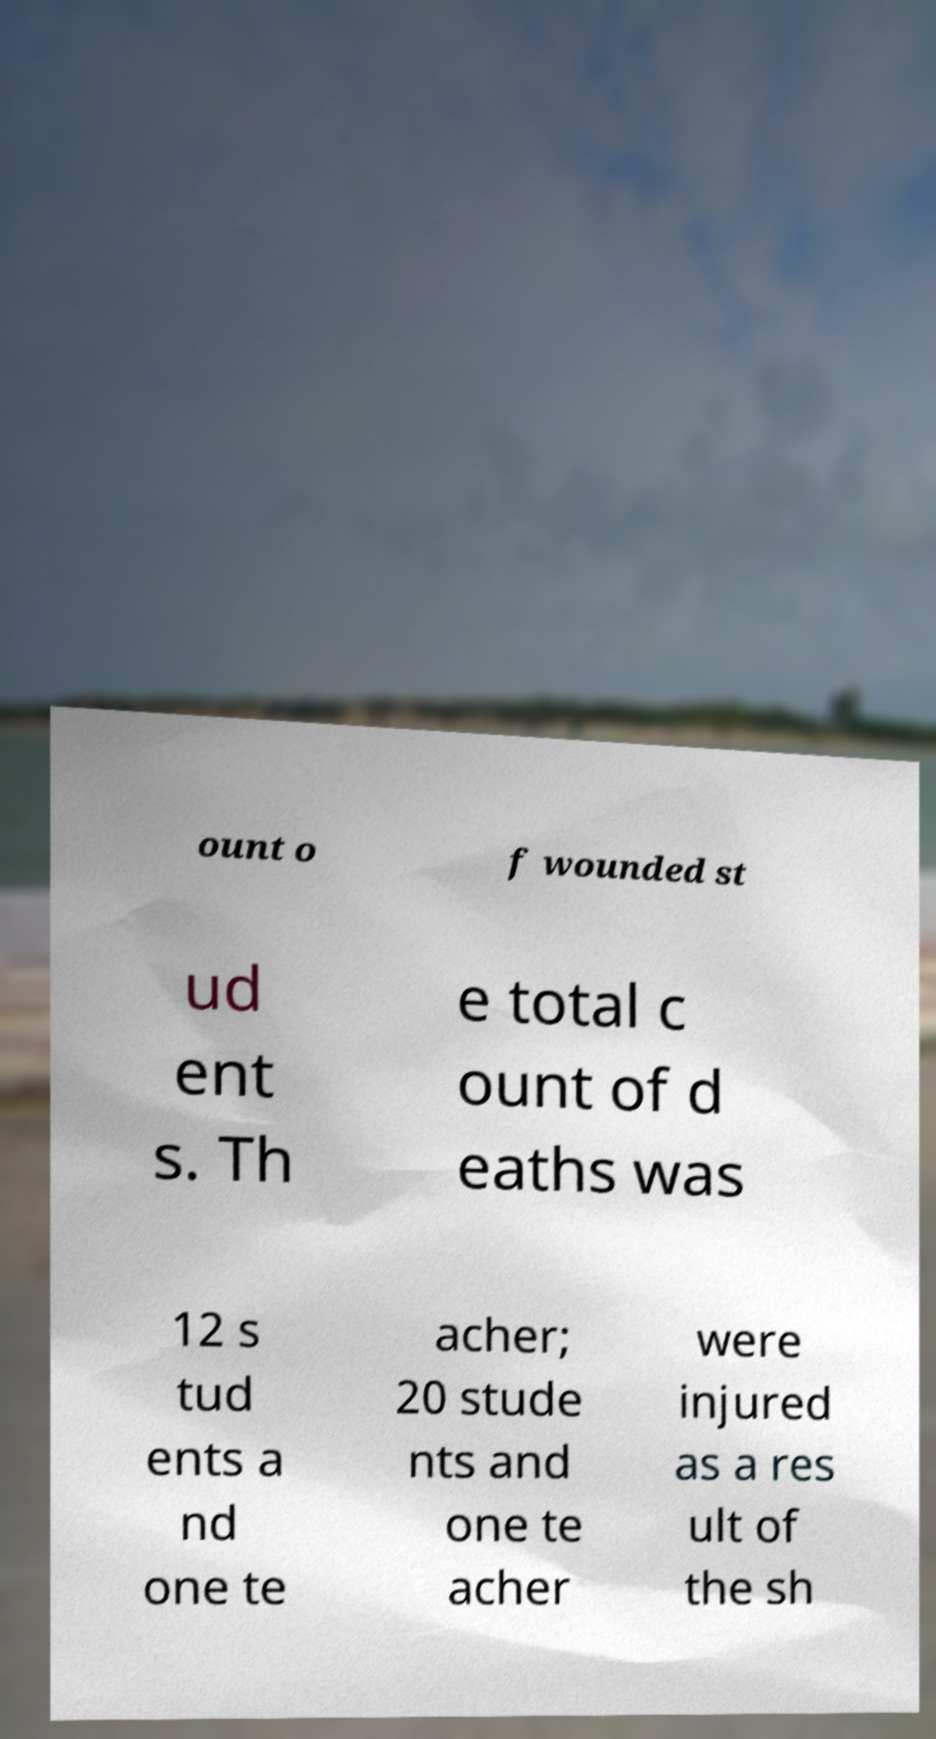Please identify and transcribe the text found in this image. ount o f wounded st ud ent s. Th e total c ount of d eaths was 12 s tud ents a nd one te acher; 20 stude nts and one te acher were injured as a res ult of the sh 